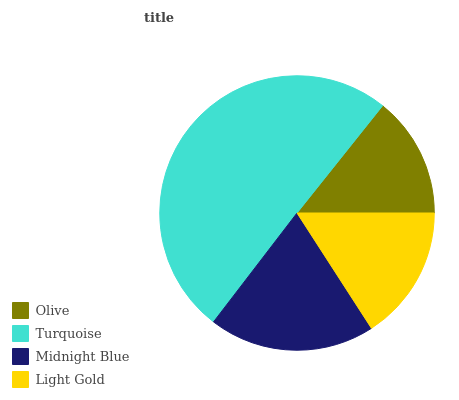Is Olive the minimum?
Answer yes or no. Yes. Is Turquoise the maximum?
Answer yes or no. Yes. Is Midnight Blue the minimum?
Answer yes or no. No. Is Midnight Blue the maximum?
Answer yes or no. No. Is Turquoise greater than Midnight Blue?
Answer yes or no. Yes. Is Midnight Blue less than Turquoise?
Answer yes or no. Yes. Is Midnight Blue greater than Turquoise?
Answer yes or no. No. Is Turquoise less than Midnight Blue?
Answer yes or no. No. Is Midnight Blue the high median?
Answer yes or no. Yes. Is Light Gold the low median?
Answer yes or no. Yes. Is Light Gold the high median?
Answer yes or no. No. Is Olive the low median?
Answer yes or no. No. 